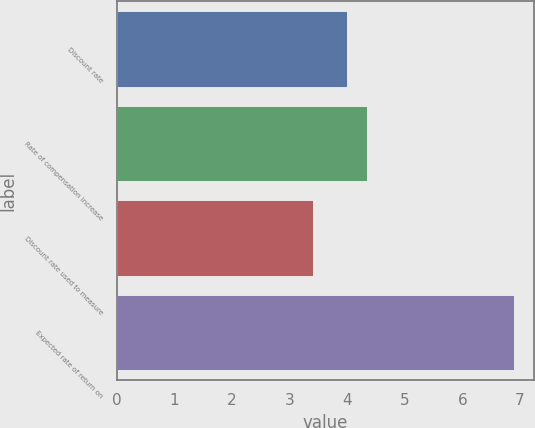<chart> <loc_0><loc_0><loc_500><loc_500><bar_chart><fcel>Discount rate<fcel>Rate of compensation increase<fcel>Discount rate used to measure<fcel>Expected rate of return on<nl><fcel>4<fcel>4.35<fcel>3.4<fcel>6.9<nl></chart> 